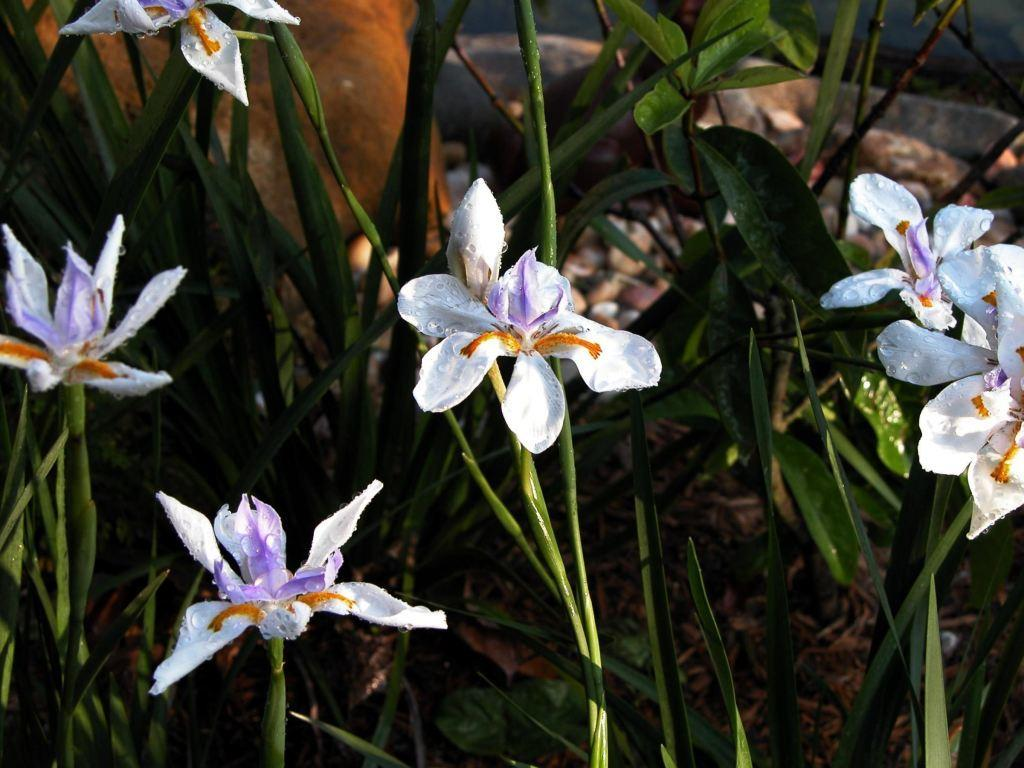What colors are the flowers in the image? The flowers in the image are white and purple. What color are the leaves in the image? The leaves in the image are green. Can you see any smoke coming from the flowers in the image? There is no smoke present in the image; it features flowers and leaves. Are there any cherries visible among the flowers in the image? There are no cherries present in the image; it features flowers and leaves. 